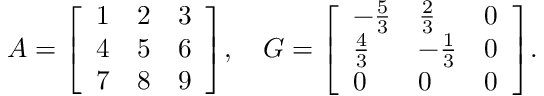Convert formula to latex. <formula><loc_0><loc_0><loc_500><loc_500>A = { \left [ \begin{array} { l l l } { 1 } & { 2 } & { 3 } \\ { 4 } & { 5 } & { 6 } \\ { 7 } & { 8 } & { 9 } \end{array} \right ] } , \quad G = { \left [ \begin{array} { l l l } { - { \frac { 5 } { 3 } } } & { { \frac { 2 } { 3 } } } & { 0 } \\ { { \frac { 4 } { 3 } } } & { - { \frac { 1 } { 3 } } } & { 0 } \\ { 0 } & { 0 } & { 0 } \end{array} \right ] } .</formula> 